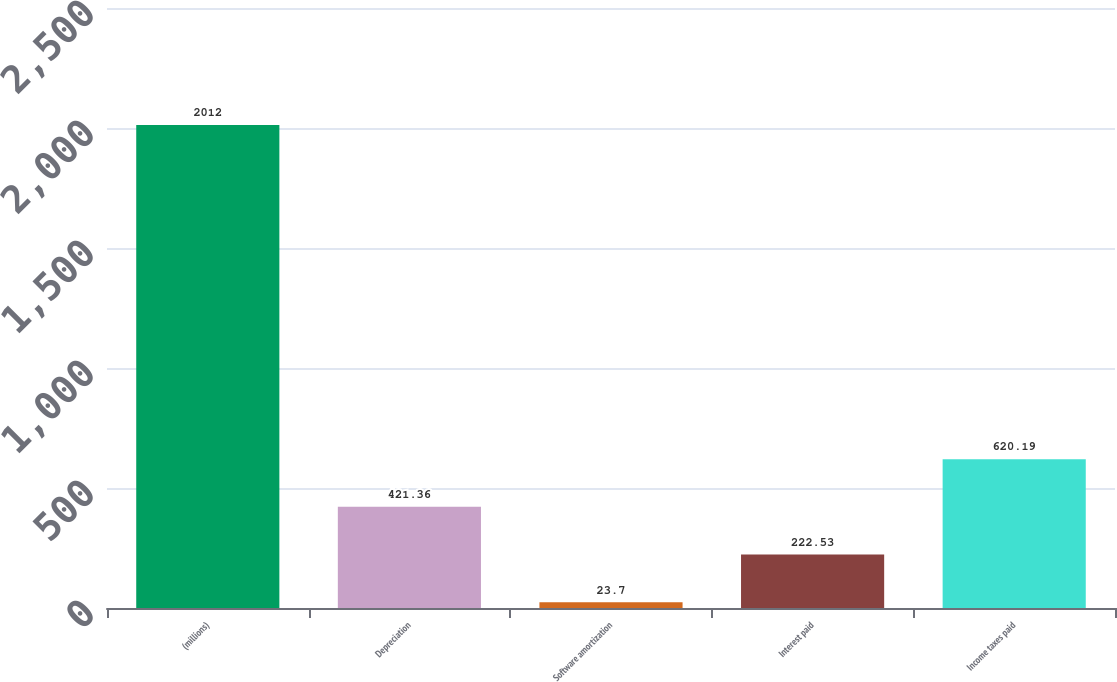<chart> <loc_0><loc_0><loc_500><loc_500><bar_chart><fcel>(millions)<fcel>Depreciation<fcel>Software amortization<fcel>Interest paid<fcel>Income taxes paid<nl><fcel>2012<fcel>421.36<fcel>23.7<fcel>222.53<fcel>620.19<nl></chart> 